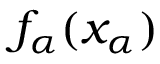<formula> <loc_0><loc_0><loc_500><loc_500>f _ { \alpha } ( x _ { \alpha } )</formula> 